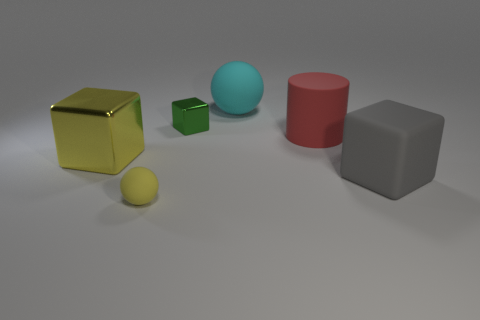The large shiny object that is the same color as the tiny matte object is what shape?
Your answer should be very brief. Cube. What number of objects are either red cylinders or big matte objects that are on the right side of the red cylinder?
Ensure brevity in your answer.  2. There is a rubber ball that is in front of the large shiny cube; does it have the same size as the rubber thing that is behind the green block?
Provide a succinct answer. No. What number of other large rubber things are the same shape as the big yellow object?
Ensure brevity in your answer.  1. There is a cyan thing that is the same material as the cylinder; what is its shape?
Provide a succinct answer. Sphere. What is the material of the large cube that is left of the ball that is on the right side of the tiny object on the left side of the small green thing?
Your answer should be compact. Metal. There is a cyan sphere; is its size the same as the ball in front of the big gray rubber block?
Offer a terse response. No. What material is the large yellow thing that is the same shape as the green shiny thing?
Your response must be concise. Metal. How big is the metallic thing that is on the right side of the big block that is left of the small object that is in front of the tiny metallic cube?
Ensure brevity in your answer.  Small. Does the rubber cube have the same size as the yellow cube?
Keep it short and to the point. Yes. 